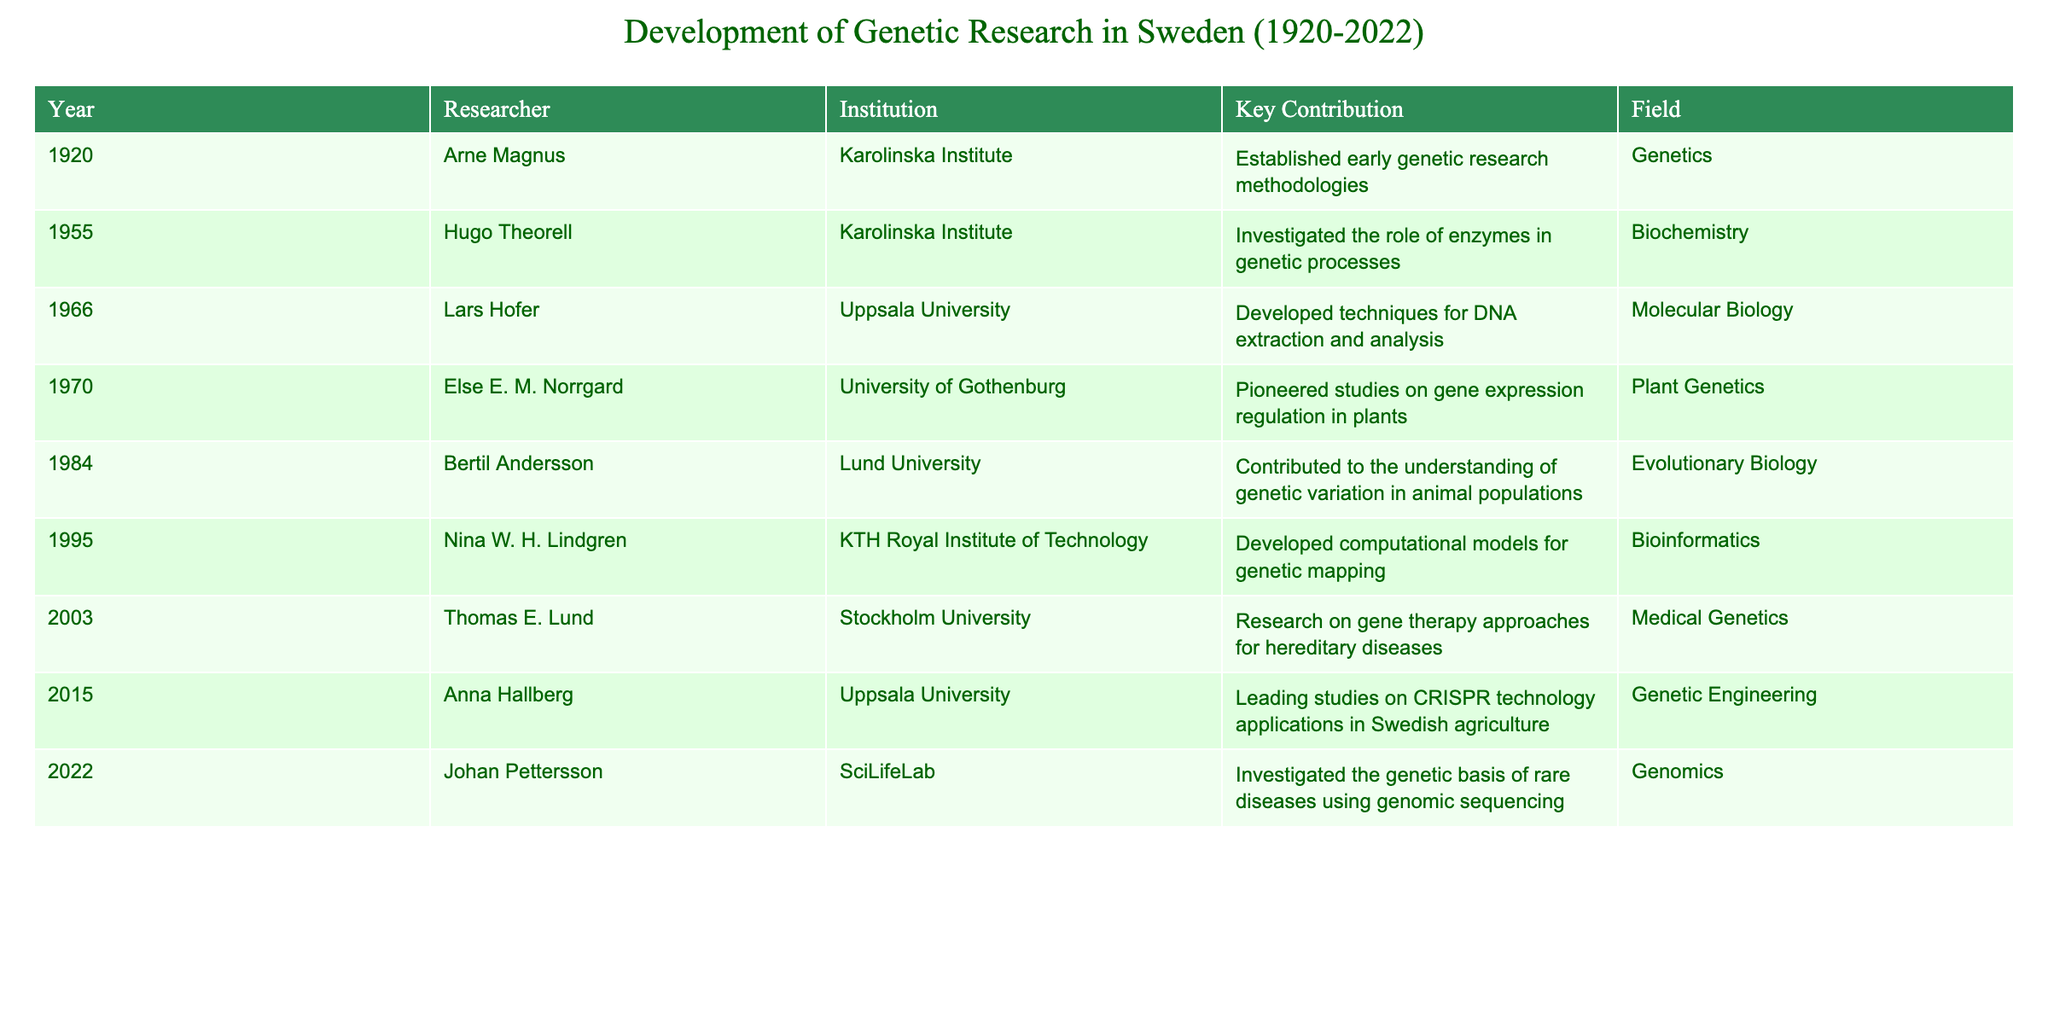What year did Arne Magnus contribute to the field of genetics? Arne Magnus is listed in the table with the year 1920, indicating when he established early genetic research methodologies.
Answer: 1920 Who was the researcher associated with gene therapy in 2003? The table indicates that Thomas E. Lund from Stockholm University conducted research on gene therapy approaches for hereditary diseases in the year 2003.
Answer: Thomas E. Lund How many researchers contributed to Plant Genetics in the table? The table shows that only Else E. M. Norrgard, who worked at the University of Gothenburg, is listed under Plant Genetics in the year 1970, making the count one researcher.
Answer: 1 What is the average year of contribution for researchers from Lund University? Bertil Andersson from Lund University contributed in 1984, so to find the average, we take that single value: average = 1984/1 = 1984, since there is only one entry from Lund University.
Answer: 1984 Did Johan Pettersson's research focus on genetic mapping? The table states that Johan Pettersson's research in 2022 investigated the genetic basis of rare diseases using genomic sequencing, which does not involve genetic mapping specifically.
Answer: No Which field saw contributions from researchers in both the 20th and 21st centuries, according to the table? The table lists several fields along with their corresponding years. Fields like Medical Genetics (from Thomas E. Lund in 2003) and Genetics (from Arne Magnus in 1920) indicate that both the fields are present in the 20th and 21st centuries. Therefore, the field of Genetics has contributions from both time frames.
Answer: Genetics How many researchers mentioned in the table focused on the field of Bioinformatics? According to the table, Nina W. H. Lindgren is the only researcher noted for her work in Bioinformatics in 1995, which means the number of researchers in this field is one.
Answer: 1 Which two institutions contributed researchers in the year 2015? The year 2015 features Anna Hallberg from Uppsala University, and the matrix does not indicate a second institution with a researcher contribution for that year. Thus, Uppsala University is the only institution listed with a contribution for 2015.
Answer: Uppsala University What were the key contributions of researchers in the field of Evolutionary Biology? The table indicates that Bertil Andersson contributed to the understanding of genetic variation in animal populations in the year 1984 under the field of Evolutionary Biology, marking the only contribution in this field.
Answer: Genetic variation in animal populations 